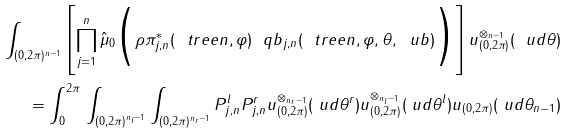<formula> <loc_0><loc_0><loc_500><loc_500>\int _ { ( 0 , 2 \pi ) ^ { n - 1 } } \left [ \prod _ { j = 1 } ^ { n } \hat { \mu } _ { 0 } \Big { ( } \rho \pi _ { j , n } ^ { \ast } ( \ t r e e n , \varphi ) \ q b _ { j , n } ( \ t r e e n , \varphi , \theta , \ u b ) \Big { ) } \right ] u _ { ( 0 , 2 \pi ) } ^ { \otimes _ { n - 1 } } ( \ u d \theta ) \\ = \int _ { 0 } ^ { 2 \pi } \, \int _ { ( 0 , 2 \pi ) ^ { n _ { l } - 1 } } \int _ { ( 0 , 2 \pi ) ^ { n _ { r } - 1 } } P _ { j , n } ^ { l } P _ { j , n } ^ { r } u _ { ( 0 , 2 \pi ) } ^ { \otimes _ { n _ { r } - 1 } } ( \ u d \theta ^ { r } ) u _ { ( 0 , 2 \pi ) } ^ { \otimes _ { n _ { l } - 1 } } ( \ u d \theta ^ { l } ) u _ { ( 0 , 2 \pi ) } ( \ u d \theta _ { n - 1 } )</formula> 